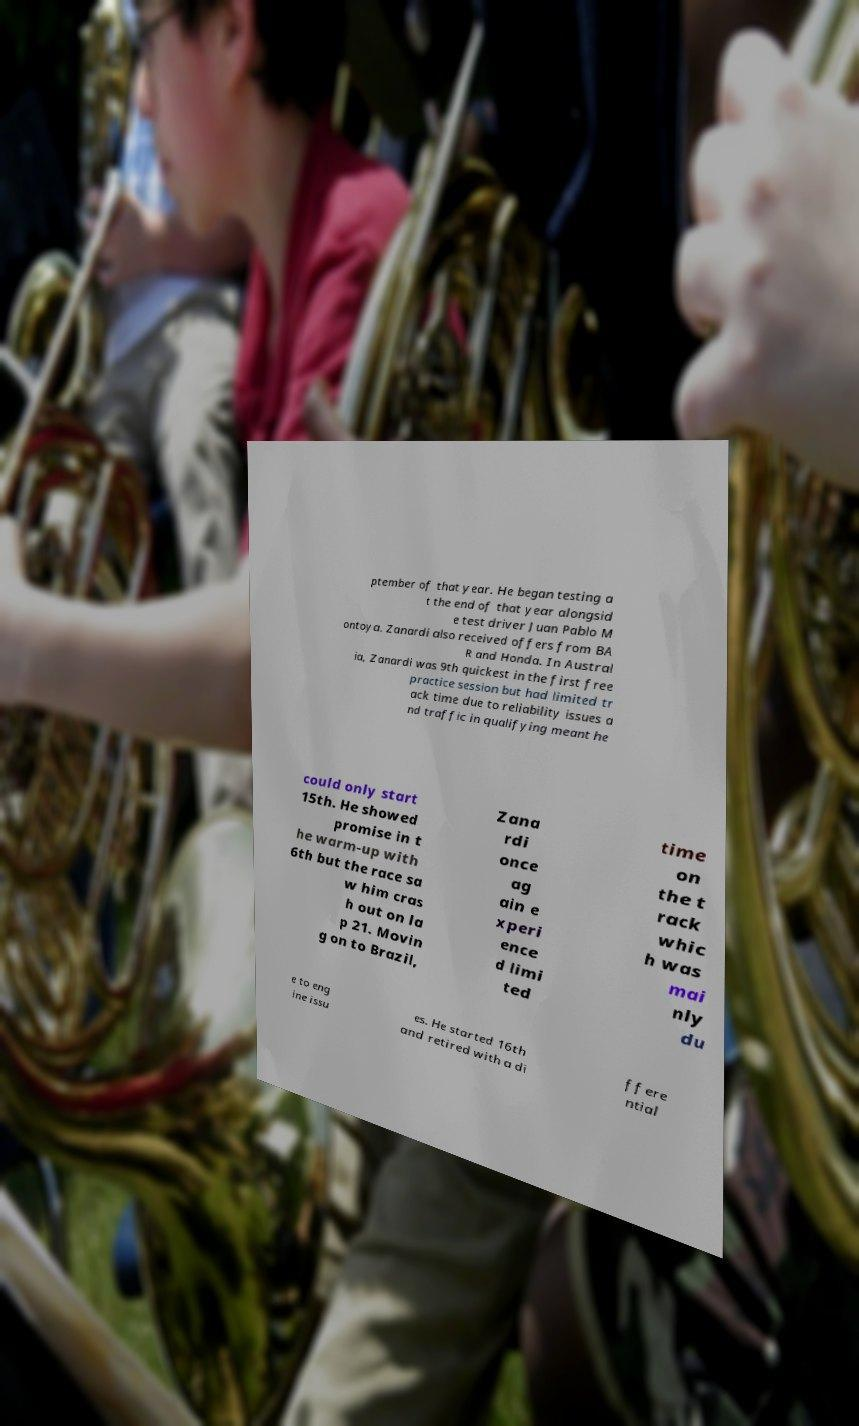For documentation purposes, I need the text within this image transcribed. Could you provide that? ptember of that year. He began testing a t the end of that year alongsid e test driver Juan Pablo M ontoya. Zanardi also received offers from BA R and Honda. In Austral ia, Zanardi was 9th quickest in the first free practice session but had limited tr ack time due to reliability issues a nd traffic in qualifying meant he could only start 15th. He showed promise in t he warm-up with 6th but the race sa w him cras h out on la p 21. Movin g on to Brazil, Zana rdi once ag ain e xperi ence d limi ted time on the t rack whic h was mai nly du e to eng ine issu es. He started 16th and retired with a di ffere ntial 